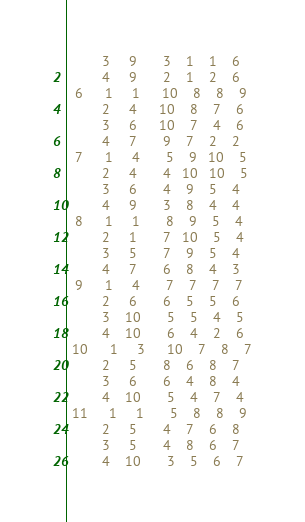Convert code to text. <code><loc_0><loc_0><loc_500><loc_500><_ObjectiveC_>         3     9       3    1    1    6
         4     9       2    1    2    6
  6      1     1      10    8    8    9
         2     4      10    8    7    6
         3     6      10    7    4    6
         4     7       9    7    2    2
  7      1     4       5    9   10    5
         2     4       4   10   10    5
         3     6       4    9    5    4
         4     9       3    8    4    4
  8      1     1       8    9    5    4
         2     1       7   10    5    4
         3     5       7    9    5    4
         4     7       6    8    4    3
  9      1     4       7    7    7    7
         2     6       6    5    5    6
         3    10       5    5    4    5
         4    10       6    4    2    6
 10      1     3      10    7    8    7
         2     5       8    6    8    7
         3     6       6    4    8    4
         4    10       5    4    7    4
 11      1     1       5    8    8    9
         2     5       4    7    6    8
         3     5       4    8    6    7
         4    10       3    5    6    7</code> 